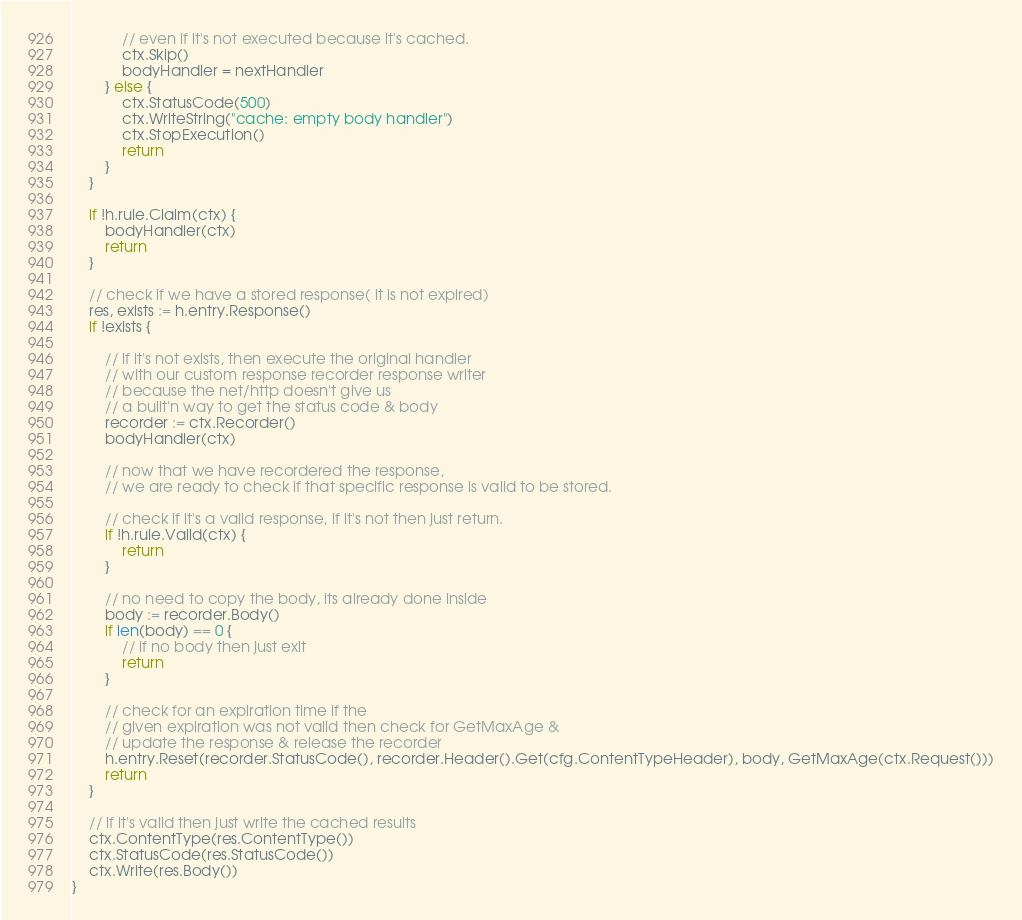<code> <loc_0><loc_0><loc_500><loc_500><_Go_>			// even if it's not executed because it's cached.
			ctx.Skip()
			bodyHandler = nextHandler
		} else {
			ctx.StatusCode(500)
			ctx.WriteString("cache: empty body handler")
			ctx.StopExecution()
			return
		}
	}

	if !h.rule.Claim(ctx) {
		bodyHandler(ctx)
		return
	}

	// check if we have a stored response( it is not expired)
	res, exists := h.entry.Response()
	if !exists {

		// if it's not exists, then execute the original handler
		// with our custom response recorder response writer
		// because the net/http doesn't give us
		// a built'n way to get the status code & body
		recorder := ctx.Recorder()
		bodyHandler(ctx)

		// now that we have recordered the response,
		// we are ready to check if that specific response is valid to be stored.

		// check if it's a valid response, if it's not then just return.
		if !h.rule.Valid(ctx) {
			return
		}

		// no need to copy the body, its already done inside
		body := recorder.Body()
		if len(body) == 0 {
			// if no body then just exit
			return
		}

		// check for an expiration time if the
		// given expiration was not valid then check for GetMaxAge &
		// update the response & release the recorder
		h.entry.Reset(recorder.StatusCode(), recorder.Header().Get(cfg.ContentTypeHeader), body, GetMaxAge(ctx.Request()))
		return
	}

	// if it's valid then just write the cached results
	ctx.ContentType(res.ContentType())
	ctx.StatusCode(res.StatusCode())
	ctx.Write(res.Body())
}
</code> 